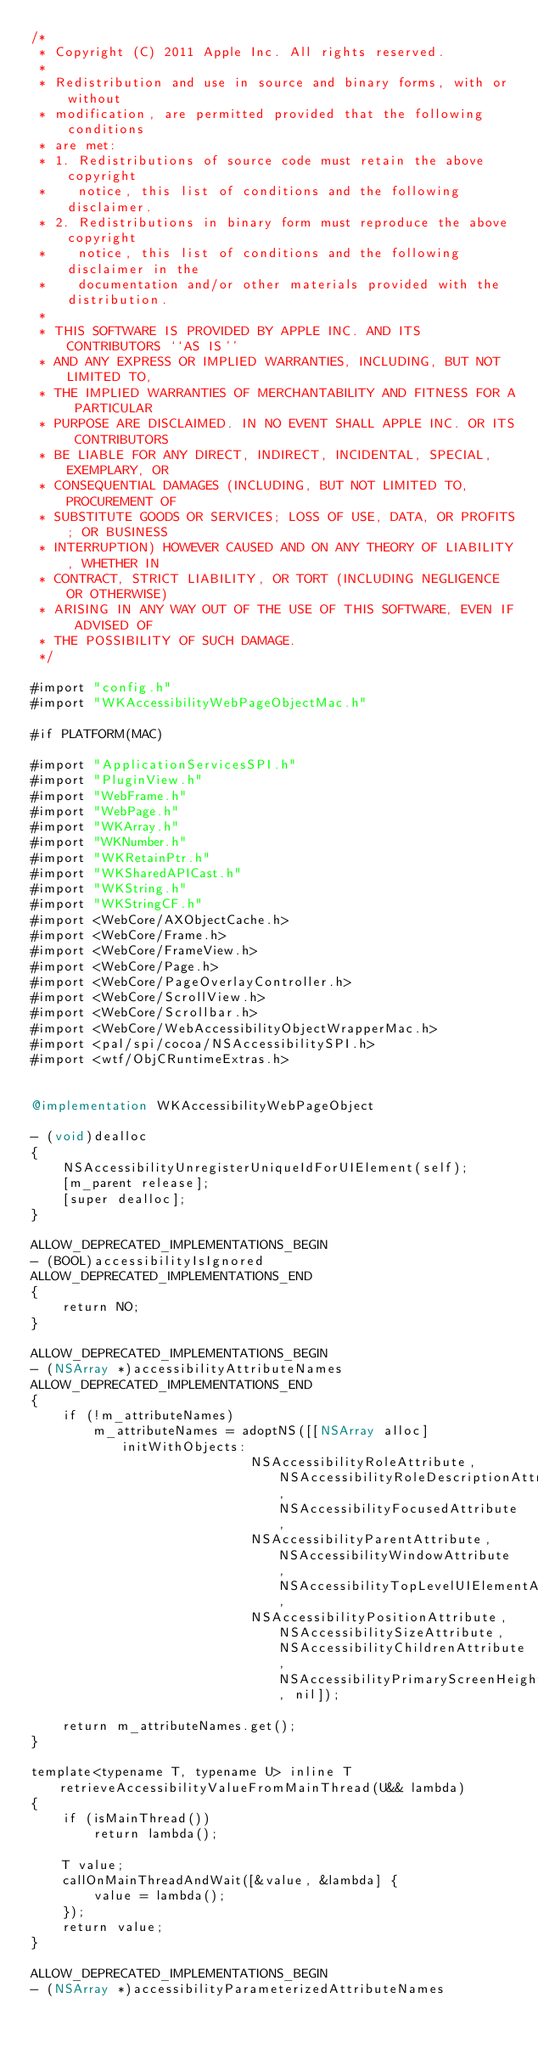Convert code to text. <code><loc_0><loc_0><loc_500><loc_500><_ObjectiveC_>/*
 * Copyright (C) 2011 Apple Inc. All rights reserved.
 *
 * Redistribution and use in source and binary forms, with or without
 * modification, are permitted provided that the following conditions
 * are met:
 * 1. Redistributions of source code must retain the above copyright
 *    notice, this list of conditions and the following disclaimer.
 * 2. Redistributions in binary form must reproduce the above copyright
 *    notice, this list of conditions and the following disclaimer in the
 *    documentation and/or other materials provided with the distribution.
 *
 * THIS SOFTWARE IS PROVIDED BY APPLE INC. AND ITS CONTRIBUTORS ``AS IS''
 * AND ANY EXPRESS OR IMPLIED WARRANTIES, INCLUDING, BUT NOT LIMITED TO,
 * THE IMPLIED WARRANTIES OF MERCHANTABILITY AND FITNESS FOR A PARTICULAR
 * PURPOSE ARE DISCLAIMED. IN NO EVENT SHALL APPLE INC. OR ITS CONTRIBUTORS
 * BE LIABLE FOR ANY DIRECT, INDIRECT, INCIDENTAL, SPECIAL, EXEMPLARY, OR
 * CONSEQUENTIAL DAMAGES (INCLUDING, BUT NOT LIMITED TO, PROCUREMENT OF
 * SUBSTITUTE GOODS OR SERVICES; LOSS OF USE, DATA, OR PROFITS; OR BUSINESS
 * INTERRUPTION) HOWEVER CAUSED AND ON ANY THEORY OF LIABILITY, WHETHER IN
 * CONTRACT, STRICT LIABILITY, OR TORT (INCLUDING NEGLIGENCE OR OTHERWISE)
 * ARISING IN ANY WAY OUT OF THE USE OF THIS SOFTWARE, EVEN IF ADVISED OF
 * THE POSSIBILITY OF SUCH DAMAGE.
 */

#import "config.h"
#import "WKAccessibilityWebPageObjectMac.h"

#if PLATFORM(MAC)

#import "ApplicationServicesSPI.h"
#import "PluginView.h"
#import "WebFrame.h"
#import "WebPage.h"
#import "WKArray.h"
#import "WKNumber.h"
#import "WKRetainPtr.h"
#import "WKSharedAPICast.h"
#import "WKString.h"
#import "WKStringCF.h"
#import <WebCore/AXObjectCache.h>
#import <WebCore/Frame.h>
#import <WebCore/FrameView.h>
#import <WebCore/Page.h>
#import <WebCore/PageOverlayController.h>
#import <WebCore/ScrollView.h>
#import <WebCore/Scrollbar.h>
#import <WebCore/WebAccessibilityObjectWrapperMac.h>
#import <pal/spi/cocoa/NSAccessibilitySPI.h>
#import <wtf/ObjCRuntimeExtras.h>


@implementation WKAccessibilityWebPageObject

- (void)dealloc
{
    NSAccessibilityUnregisterUniqueIdForUIElement(self);
    [m_parent release];
    [super dealloc];
}

ALLOW_DEPRECATED_IMPLEMENTATIONS_BEGIN
- (BOOL)accessibilityIsIgnored
ALLOW_DEPRECATED_IMPLEMENTATIONS_END
{
    return NO;
}

ALLOW_DEPRECATED_IMPLEMENTATIONS_BEGIN
- (NSArray *)accessibilityAttributeNames
ALLOW_DEPRECATED_IMPLEMENTATIONS_END
{
    if (!m_attributeNames)
        m_attributeNames = adoptNS([[NSArray alloc] initWithObjects:
                            NSAccessibilityRoleAttribute, NSAccessibilityRoleDescriptionAttribute, NSAccessibilityFocusedAttribute,
                            NSAccessibilityParentAttribute, NSAccessibilityWindowAttribute, NSAccessibilityTopLevelUIElementAttribute,
                            NSAccessibilityPositionAttribute, NSAccessibilitySizeAttribute, NSAccessibilityChildrenAttribute, NSAccessibilityPrimaryScreenHeightAttribute, nil]);
    
    return m_attributeNames.get();
}

template<typename T, typename U> inline T retrieveAccessibilityValueFromMainThread(U&& lambda)
{
    if (isMainThread())
        return lambda();

    T value;
    callOnMainThreadAndWait([&value, &lambda] {
        value = lambda();
    });
    return value;
}

ALLOW_DEPRECATED_IMPLEMENTATIONS_BEGIN
- (NSArray *)accessibilityParameterizedAttributeNames</code> 